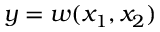Convert formula to latex. <formula><loc_0><loc_0><loc_500><loc_500>y = w ( x _ { 1 } , x _ { 2 } )</formula> 